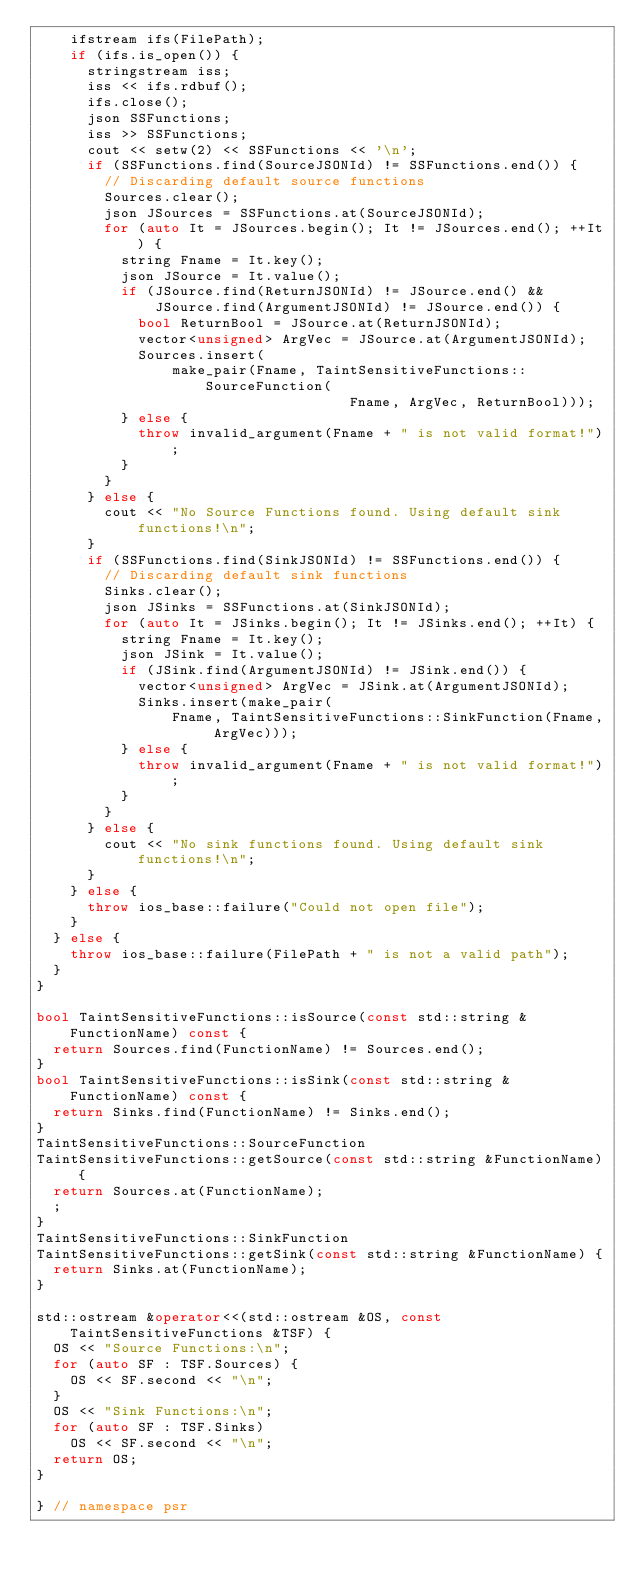Convert code to text. <code><loc_0><loc_0><loc_500><loc_500><_C++_>    ifstream ifs(FilePath);
    if (ifs.is_open()) {
      stringstream iss;
      iss << ifs.rdbuf();
      ifs.close();
      json SSFunctions;
      iss >> SSFunctions;
      cout << setw(2) << SSFunctions << '\n';
      if (SSFunctions.find(SourceJSONId) != SSFunctions.end()) {
        // Discarding default source functions
        Sources.clear();
        json JSources = SSFunctions.at(SourceJSONId);
        for (auto It = JSources.begin(); It != JSources.end(); ++It) {
          string Fname = It.key();
          json JSource = It.value();
          if (JSource.find(ReturnJSONId) != JSource.end() &&
              JSource.find(ArgumentJSONId) != JSource.end()) {
            bool ReturnBool = JSource.at(ReturnJSONId);
            vector<unsigned> ArgVec = JSource.at(ArgumentJSONId);
            Sources.insert(
                make_pair(Fname, TaintSensitiveFunctions::SourceFunction(
                                     Fname, ArgVec, ReturnBool)));
          } else {
            throw invalid_argument(Fname + " is not valid format!");
          }
        }
      } else {
        cout << "No Source Functions found. Using default sink functions!\n";
      }
      if (SSFunctions.find(SinkJSONId) != SSFunctions.end()) {
        // Discarding default sink functions
        Sinks.clear();
        json JSinks = SSFunctions.at(SinkJSONId);
        for (auto It = JSinks.begin(); It != JSinks.end(); ++It) {
          string Fname = It.key();
          json JSink = It.value();
          if (JSink.find(ArgumentJSONId) != JSink.end()) {
            vector<unsigned> ArgVec = JSink.at(ArgumentJSONId);
            Sinks.insert(make_pair(
                Fname, TaintSensitiveFunctions::SinkFunction(Fname, ArgVec)));
          } else {
            throw invalid_argument(Fname + " is not valid format!");
          }
        }
      } else {
        cout << "No sink functions found. Using default sink functions!\n";
      }
    } else {
      throw ios_base::failure("Could not open file");
    }
  } else {
    throw ios_base::failure(FilePath + " is not a valid path");
  }
}

bool TaintSensitiveFunctions::isSource(const std::string &FunctionName) const {
  return Sources.find(FunctionName) != Sources.end();
}
bool TaintSensitiveFunctions::isSink(const std::string &FunctionName) const {
  return Sinks.find(FunctionName) != Sinks.end();
}
TaintSensitiveFunctions::SourceFunction
TaintSensitiveFunctions::getSource(const std::string &FunctionName) {
  return Sources.at(FunctionName);
  ;
}
TaintSensitiveFunctions::SinkFunction
TaintSensitiveFunctions::getSink(const std::string &FunctionName) {
  return Sinks.at(FunctionName);
}

std::ostream &operator<<(std::ostream &OS, const TaintSensitiveFunctions &TSF) {
  OS << "Source Functions:\n";
  for (auto SF : TSF.Sources) {
    OS << SF.second << "\n";
  }
  OS << "Sink Functions:\n";
  for (auto SF : TSF.Sinks)
    OS << SF.second << "\n";
  return OS;
}

} // namespace psr</code> 